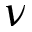<formula> <loc_0><loc_0><loc_500><loc_500>\nu</formula> 